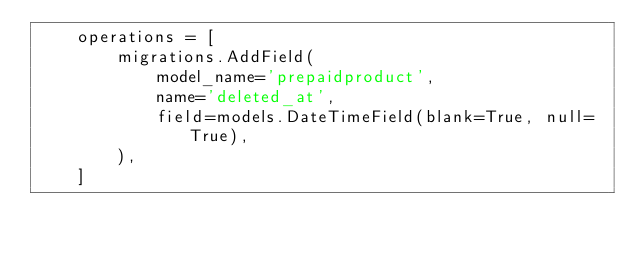Convert code to text. <code><loc_0><loc_0><loc_500><loc_500><_Python_>    operations = [
        migrations.AddField(
            model_name='prepaidproduct',
            name='deleted_at',
            field=models.DateTimeField(blank=True, null=True),
        ),
    ]
</code> 